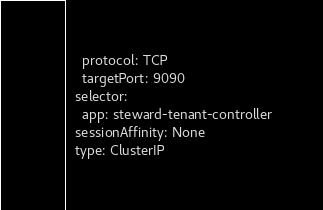<code> <loc_0><loc_0><loc_500><loc_500><_YAML_>    protocol: TCP
    targetPort: 9090
  selector:
    app: steward-tenant-controller
  sessionAffinity: None
  type: ClusterIP
</code> 